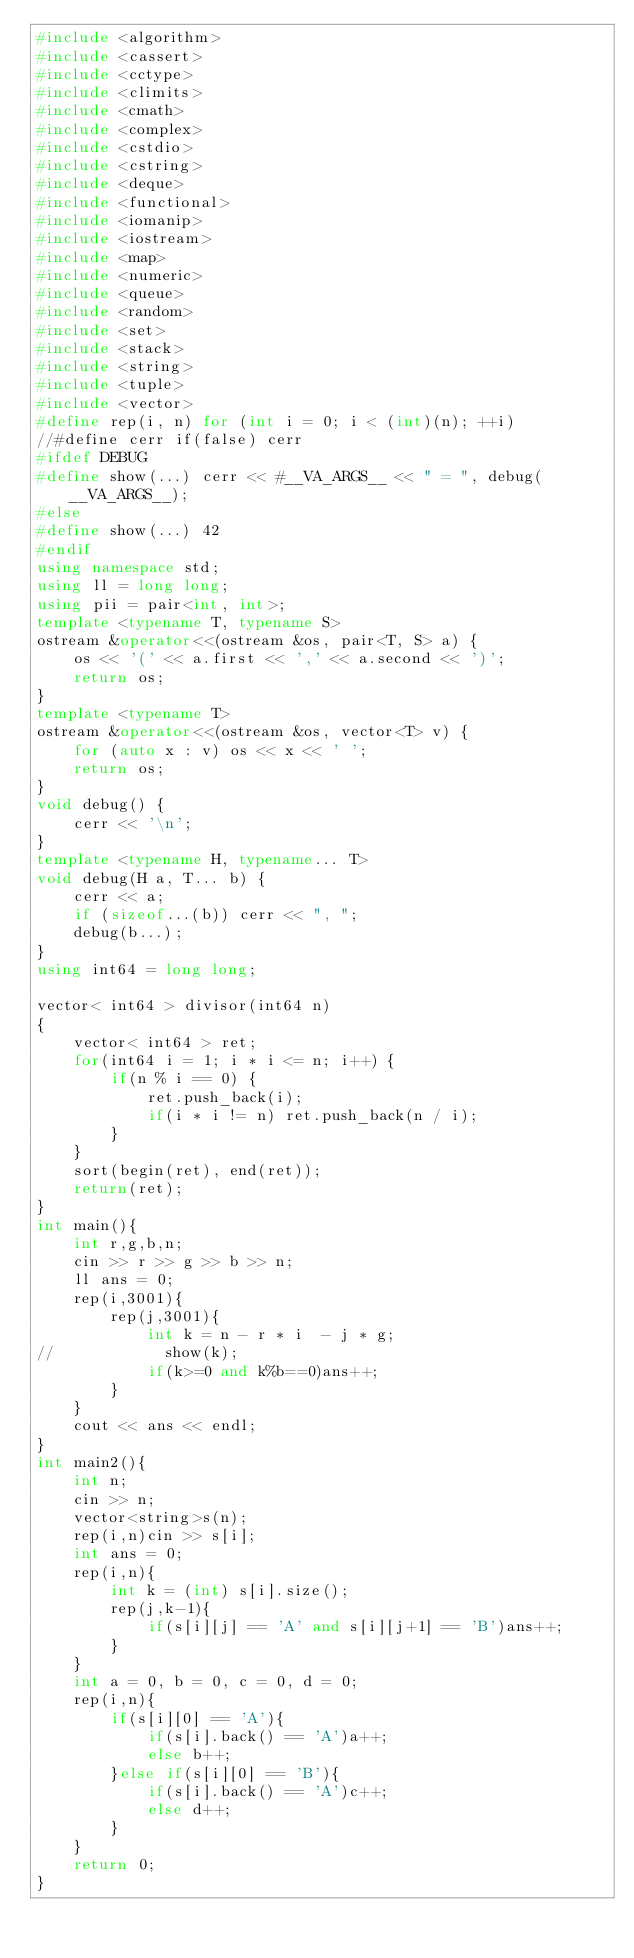<code> <loc_0><loc_0><loc_500><loc_500><_C++_>#include <algorithm>
#include <cassert>
#include <cctype>
#include <climits>
#include <cmath>
#include <complex>
#include <cstdio>
#include <cstring>
#include <deque>
#include <functional>
#include <iomanip>
#include <iostream>
#include <map>
#include <numeric>
#include <queue>
#include <random>
#include <set>
#include <stack>
#include <string>
#include <tuple>
#include <vector>
#define rep(i, n) for (int i = 0; i < (int)(n); ++i)
//#define cerr if(false) cerr
#ifdef DEBUG
#define show(...) cerr << #__VA_ARGS__ << " = ", debug(__VA_ARGS__);
#else
#define show(...) 42
#endif
using namespace std;
using ll = long long;
using pii = pair<int, int>;
template <typename T, typename S>
ostream &operator<<(ostream &os, pair<T, S> a) {
    os << '(' << a.first << ',' << a.second << ')';
    return os;
}
template <typename T>
ostream &operator<<(ostream &os, vector<T> v) {
    for (auto x : v) os << x << ' ';
    return os;
}
void debug() {
    cerr << '\n';
}
template <typename H, typename... T>
void debug(H a, T... b) {
    cerr << a;
    if (sizeof...(b)) cerr << ", ";
    debug(b...);
}
using int64 = long long;

vector< int64 > divisor(int64 n)
{
    vector< int64 > ret;
    for(int64 i = 1; i * i <= n; i++) {
        if(n % i == 0) {
            ret.push_back(i);
            if(i * i != n) ret.push_back(n / i);
        }
    }
    sort(begin(ret), end(ret));
    return(ret);
}
int main(){
    int r,g,b,n;
    cin >> r >> g >> b >> n;
    ll ans = 0;
    rep(i,3001){
        rep(j,3001){
            int k = n - r * i  - j * g;
//            show(k);
            if(k>=0 and k%b==0)ans++;
        }
    }
    cout << ans << endl;
}
int main2(){
    int n;
    cin >> n;
    vector<string>s(n);
    rep(i,n)cin >> s[i];
    int ans = 0;
    rep(i,n){
        int k = (int) s[i].size();
        rep(j,k-1){
            if(s[i][j] == 'A' and s[i][j+1] == 'B')ans++;
        }
    }
    int a = 0, b = 0, c = 0, d = 0;
    rep(i,n){
        if(s[i][0] == 'A'){
            if(s[i].back() == 'A')a++;
            else b++;
        }else if(s[i][0] == 'B'){
            if(s[i].back() == 'A')c++;
            else d++;
        }
    }
    return 0;
}</code> 